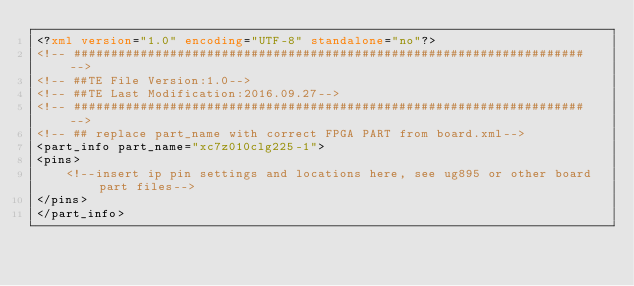Convert code to text. <code><loc_0><loc_0><loc_500><loc_500><_XML_><?xml version="1.0" encoding="UTF-8" standalone="no"?> 
<!-- ##################################################################### -->
<!-- ##TE File Version:1.0-->
<!-- ##TE Last Modification:2016.09.27-->
<!-- ##################################################################### -->
<!-- ## replace part_name with correct FPGA PART from board.xml-->
<part_info part_name="xc7z010clg225-1">
<pins>
    <!--insert ip pin settings and locations here, see ug895 or other board part files-->
</pins>
</part_info>
</code> 